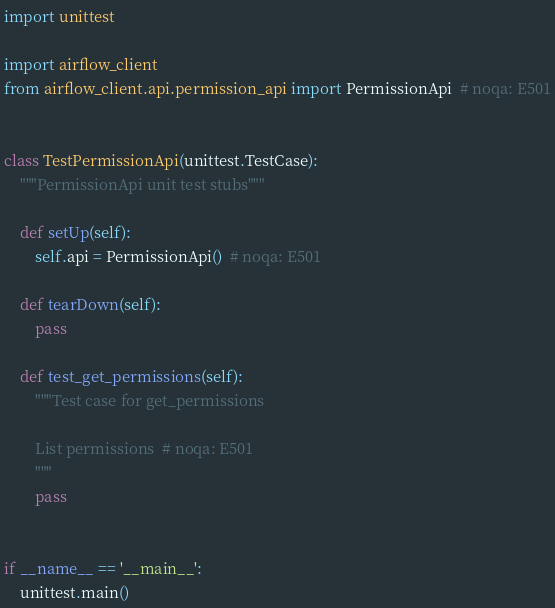<code> <loc_0><loc_0><loc_500><loc_500><_Python_>

import unittest

import airflow_client
from airflow_client.api.permission_api import PermissionApi  # noqa: E501


class TestPermissionApi(unittest.TestCase):
    """PermissionApi unit test stubs"""

    def setUp(self):
        self.api = PermissionApi()  # noqa: E501

    def tearDown(self):
        pass

    def test_get_permissions(self):
        """Test case for get_permissions

        List permissions  # noqa: E501
        """
        pass


if __name__ == '__main__':
    unittest.main()
</code> 